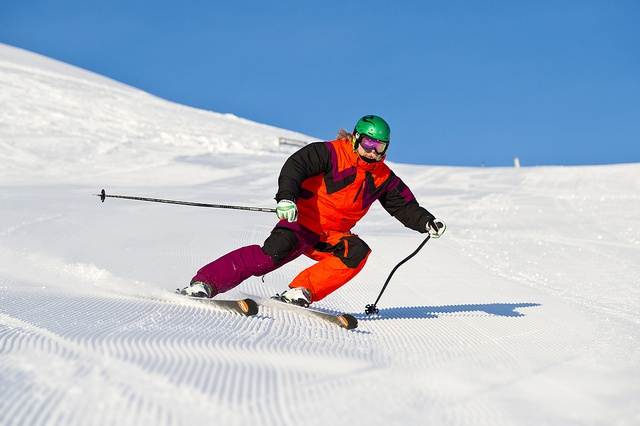Describe the objects in this image and their specific colors. I can see people in gray, black, red, and maroon tones and skis in gray, lightgray, black, and darkgray tones in this image. 